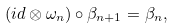<formula> <loc_0><loc_0><loc_500><loc_500>( i d \otimes \omega _ { n } ) \circ \beta _ { n + 1 } = \beta _ { n } ,</formula> 